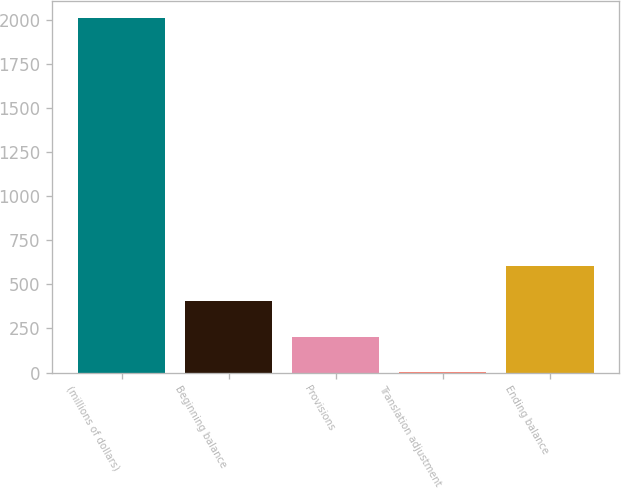Convert chart. <chart><loc_0><loc_0><loc_500><loc_500><bar_chart><fcel>(millions of dollars)<fcel>Beginning balance<fcel>Provisions<fcel>Translation adjustment<fcel>Ending balance<nl><fcel>2009<fcel>404.04<fcel>203.42<fcel>2.8<fcel>604.66<nl></chart> 